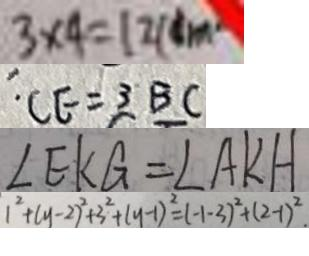Convert formula to latex. <formula><loc_0><loc_0><loc_500><loc_500>3 \times 4 = 1 2 ( d m ^ { 2 } ) 
 C E = 3 B C 
 \angle E K G = \angle A K H 
 1 ^ { 2 } + ( y - 2 ) ^ { 2 } + 3 ^ { 2 } + ( y - 1 ) ^ { 2 } = ( - 1 - 3 ) ^ { 2 } + ( 2 - 1 ) ^ { 2 } .</formula> 